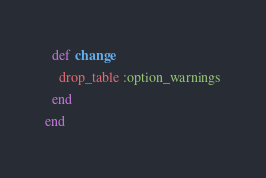<code> <loc_0><loc_0><loc_500><loc_500><_Ruby_>  def change
    drop_table :option_warnings
  end
end
</code> 